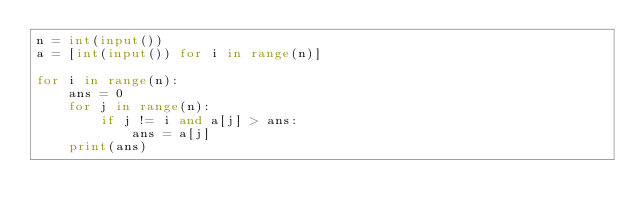Convert code to text. <code><loc_0><loc_0><loc_500><loc_500><_Python_>n = int(input())
a = [int(input()) for i in range(n)]

for i in range(n):
    ans = 0
    for j in range(n):
        if j != i and a[j] > ans:
            ans = a[j]
    print(ans)</code> 